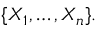Convert formula to latex. <formula><loc_0><loc_0><loc_500><loc_500>\{ X _ { 1 } , \dots , X _ { n } \} .</formula> 